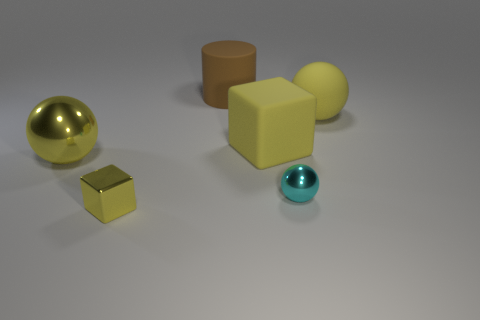The cyan ball is what size?
Your answer should be very brief. Small. What is the size of the yellow object that is in front of the yellow metal thing behind the cyan object right of the large cylinder?
Your answer should be very brief. Small. Is there a large purple cylinder that has the same material as the tiny yellow block?
Provide a short and direct response. No. What is the shape of the brown thing?
Offer a very short reply. Cylinder. There is a large ball that is made of the same material as the brown cylinder; what color is it?
Keep it short and to the point. Yellow. How many yellow things are blocks or shiny things?
Keep it short and to the point. 3. Is the number of small gray metallic cylinders greater than the number of large cylinders?
Your response must be concise. No. What number of objects are either yellow blocks in front of the cyan metal ball or objects that are in front of the brown object?
Give a very brief answer. 5. What is the color of the cube that is the same size as the yellow matte ball?
Offer a very short reply. Yellow. Is the cyan thing made of the same material as the tiny cube?
Keep it short and to the point. Yes. 